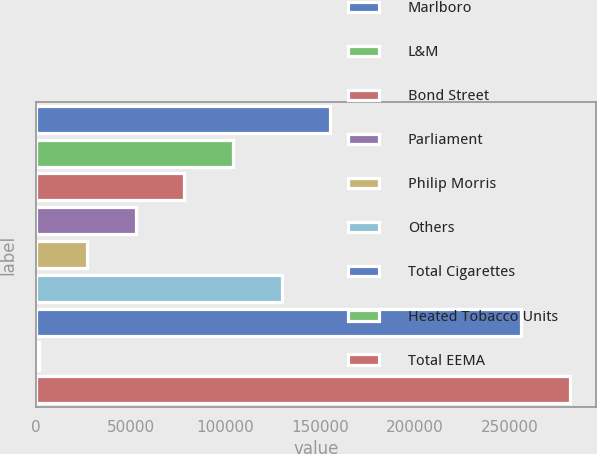Convert chart. <chart><loc_0><loc_0><loc_500><loc_500><bar_chart><fcel>Marlboro<fcel>L&M<fcel>Bond Street<fcel>Parliament<fcel>Philip Morris<fcel>Others<fcel>Total Cigarettes<fcel>Heated Tobacco Units<fcel>Total EEMA<nl><fcel>155275<fcel>104044<fcel>78428.1<fcel>52812.4<fcel>27196.7<fcel>129660<fcel>256157<fcel>1581<fcel>281773<nl></chart> 